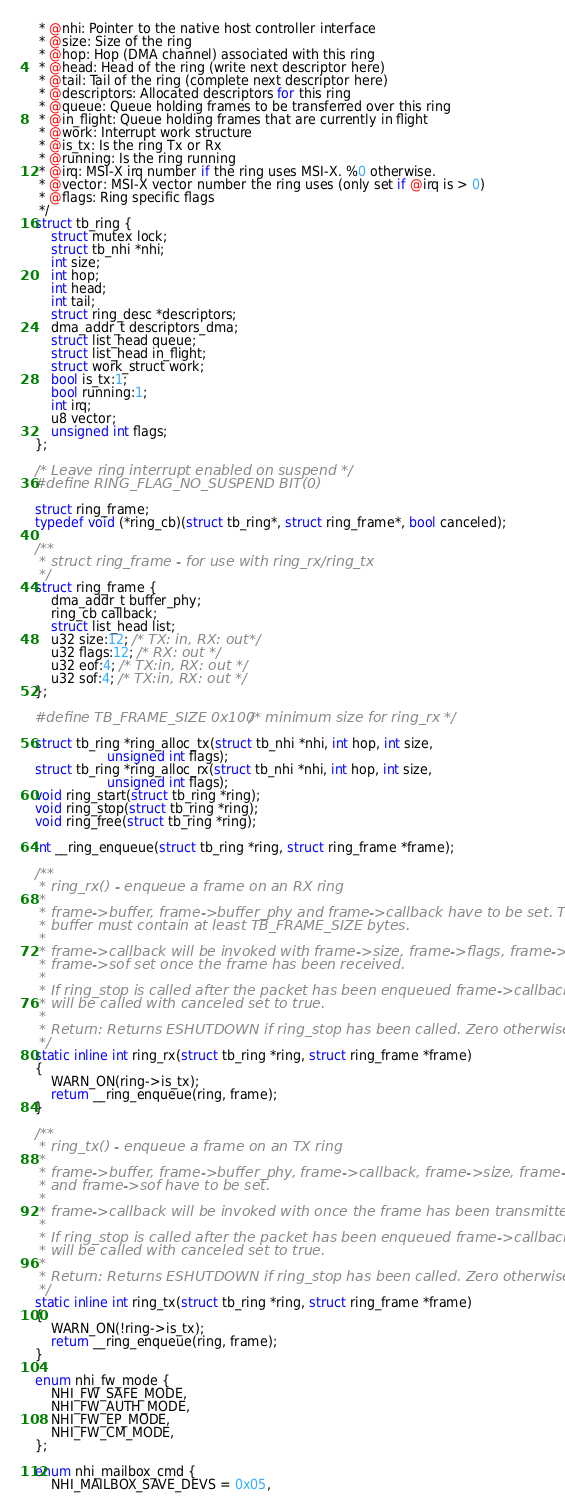<code> <loc_0><loc_0><loc_500><loc_500><_C_> * @nhi: Pointer to the native host controller interface
 * @size: Size of the ring
 * @hop: Hop (DMA channel) associated with this ring
 * @head: Head of the ring (write next descriptor here)
 * @tail: Tail of the ring (complete next descriptor here)
 * @descriptors: Allocated descriptors for this ring
 * @queue: Queue holding frames to be transferred over this ring
 * @in_flight: Queue holding frames that are currently in flight
 * @work: Interrupt work structure
 * @is_tx: Is the ring Tx or Rx
 * @running: Is the ring running
 * @irq: MSI-X irq number if the ring uses MSI-X. %0 otherwise.
 * @vector: MSI-X vector number the ring uses (only set if @irq is > 0)
 * @flags: Ring specific flags
 */
struct tb_ring {
	struct mutex lock;
	struct tb_nhi *nhi;
	int size;
	int hop;
	int head;
	int tail;
	struct ring_desc *descriptors;
	dma_addr_t descriptors_dma;
	struct list_head queue;
	struct list_head in_flight;
	struct work_struct work;
	bool is_tx:1;
	bool running:1;
	int irq;
	u8 vector;
	unsigned int flags;
};

/* Leave ring interrupt enabled on suspend */
#define RING_FLAG_NO_SUSPEND	BIT(0)

struct ring_frame;
typedef void (*ring_cb)(struct tb_ring*, struct ring_frame*, bool canceled);

/**
 * struct ring_frame - for use with ring_rx/ring_tx
 */
struct ring_frame {
	dma_addr_t buffer_phy;
	ring_cb callback;
	struct list_head list;
	u32 size:12; /* TX: in, RX: out*/
	u32 flags:12; /* RX: out */
	u32 eof:4; /* TX:in, RX: out */
	u32 sof:4; /* TX:in, RX: out */
};

#define TB_FRAME_SIZE 0x100    /* minimum size for ring_rx */

struct tb_ring *ring_alloc_tx(struct tb_nhi *nhi, int hop, int size,
			      unsigned int flags);
struct tb_ring *ring_alloc_rx(struct tb_nhi *nhi, int hop, int size,
			      unsigned int flags);
void ring_start(struct tb_ring *ring);
void ring_stop(struct tb_ring *ring);
void ring_free(struct tb_ring *ring);

int __ring_enqueue(struct tb_ring *ring, struct ring_frame *frame);

/**
 * ring_rx() - enqueue a frame on an RX ring
 *
 * frame->buffer, frame->buffer_phy and frame->callback have to be set. The
 * buffer must contain at least TB_FRAME_SIZE bytes.
 *
 * frame->callback will be invoked with frame->size, frame->flags, frame->eof,
 * frame->sof set once the frame has been received.
 *
 * If ring_stop is called after the packet has been enqueued frame->callback
 * will be called with canceled set to true.
 *
 * Return: Returns ESHUTDOWN if ring_stop has been called. Zero otherwise.
 */
static inline int ring_rx(struct tb_ring *ring, struct ring_frame *frame)
{
	WARN_ON(ring->is_tx);
	return __ring_enqueue(ring, frame);
}

/**
 * ring_tx() - enqueue a frame on an TX ring
 *
 * frame->buffer, frame->buffer_phy, frame->callback, frame->size, frame->eof
 * and frame->sof have to be set.
 *
 * frame->callback will be invoked with once the frame has been transmitted.
 *
 * If ring_stop is called after the packet has been enqueued frame->callback
 * will be called with canceled set to true.
 *
 * Return: Returns ESHUTDOWN if ring_stop has been called. Zero otherwise.
 */
static inline int ring_tx(struct tb_ring *ring, struct ring_frame *frame)
{
	WARN_ON(!ring->is_tx);
	return __ring_enqueue(ring, frame);
}

enum nhi_fw_mode {
	NHI_FW_SAFE_MODE,
	NHI_FW_AUTH_MODE,
	NHI_FW_EP_MODE,
	NHI_FW_CM_MODE,
};

enum nhi_mailbox_cmd {
	NHI_MAILBOX_SAVE_DEVS = 0x05,</code> 